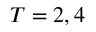<formula> <loc_0><loc_0><loc_500><loc_500>T = 2 , 4</formula> 